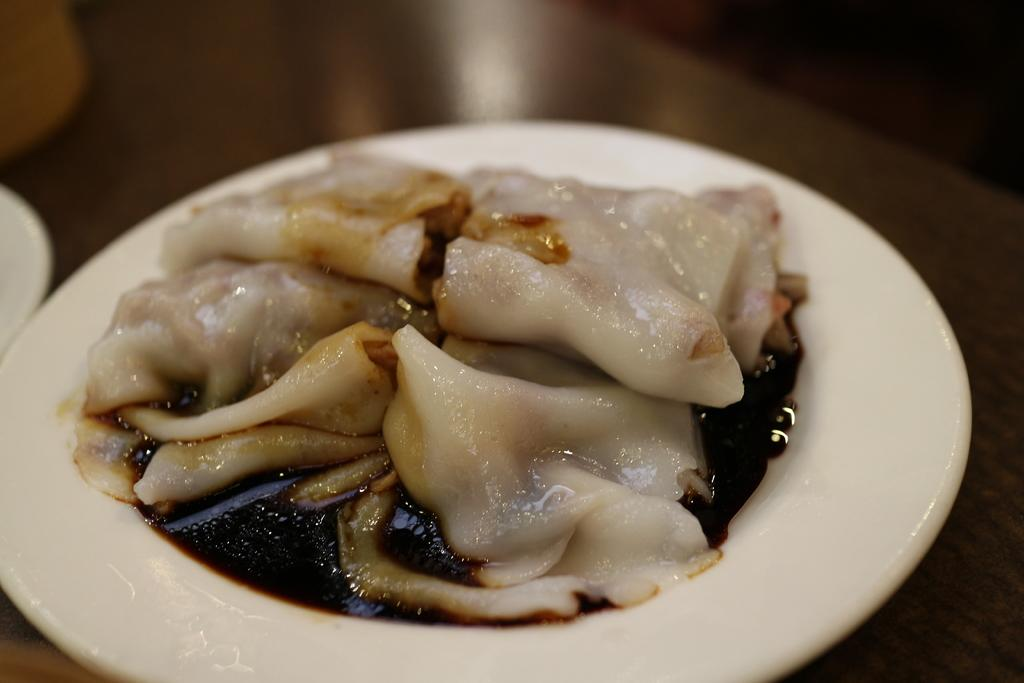What is present on the plate in the image? The plate contains a food item. Can you describe the location of the plate in the image? The plate is on a surface. What type of lace can be seen on the plate in the image? There is no lace present on the plate in the image. What attraction is visible in the background of the image? There is no background or attraction visible in the image; it only features a plate with a food item on a surface. 